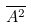Convert formula to latex. <formula><loc_0><loc_0><loc_500><loc_500>\overline { A ^ { 2 } }</formula> 